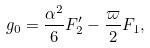<formula> <loc_0><loc_0><loc_500><loc_500>g _ { 0 } = \frac { \alpha ^ { 2 } } { 6 } F _ { 2 } ^ { \prime } - \frac { \varpi } { 2 } F _ { 1 } ,</formula> 